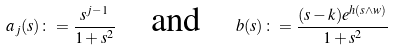Convert formula to latex. <formula><loc_0><loc_0><loc_500><loc_500>a _ { j } ( s ) \colon = \frac { s ^ { j - 1 } } { 1 + s ^ { 2 } } \quad \text {and} \quad b ( s ) \colon = \frac { ( s - k ) e ^ { h ( s \wedge w ) } } { 1 + s ^ { 2 } }</formula> 